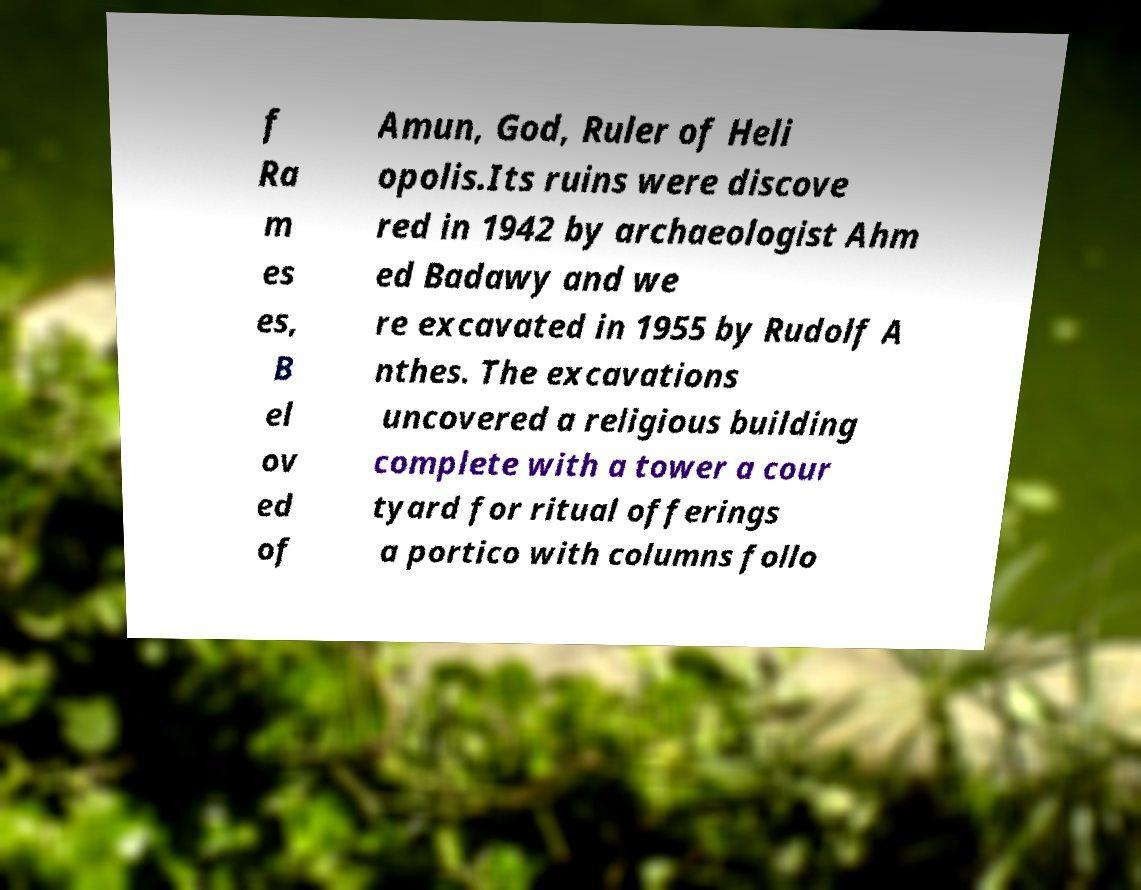Can you read and provide the text displayed in the image?This photo seems to have some interesting text. Can you extract and type it out for me? f Ra m es es, B el ov ed of Amun, God, Ruler of Heli opolis.Its ruins were discove red in 1942 by archaeologist Ahm ed Badawy and we re excavated in 1955 by Rudolf A nthes. The excavations uncovered a religious building complete with a tower a cour tyard for ritual offerings a portico with columns follo 